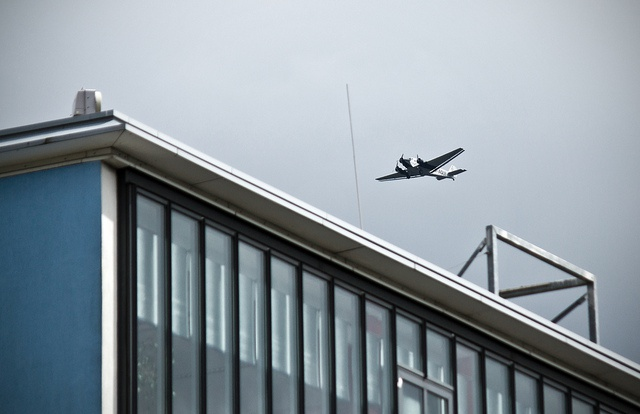Describe the objects in this image and their specific colors. I can see a airplane in gray, black, lightgray, and darkgray tones in this image. 